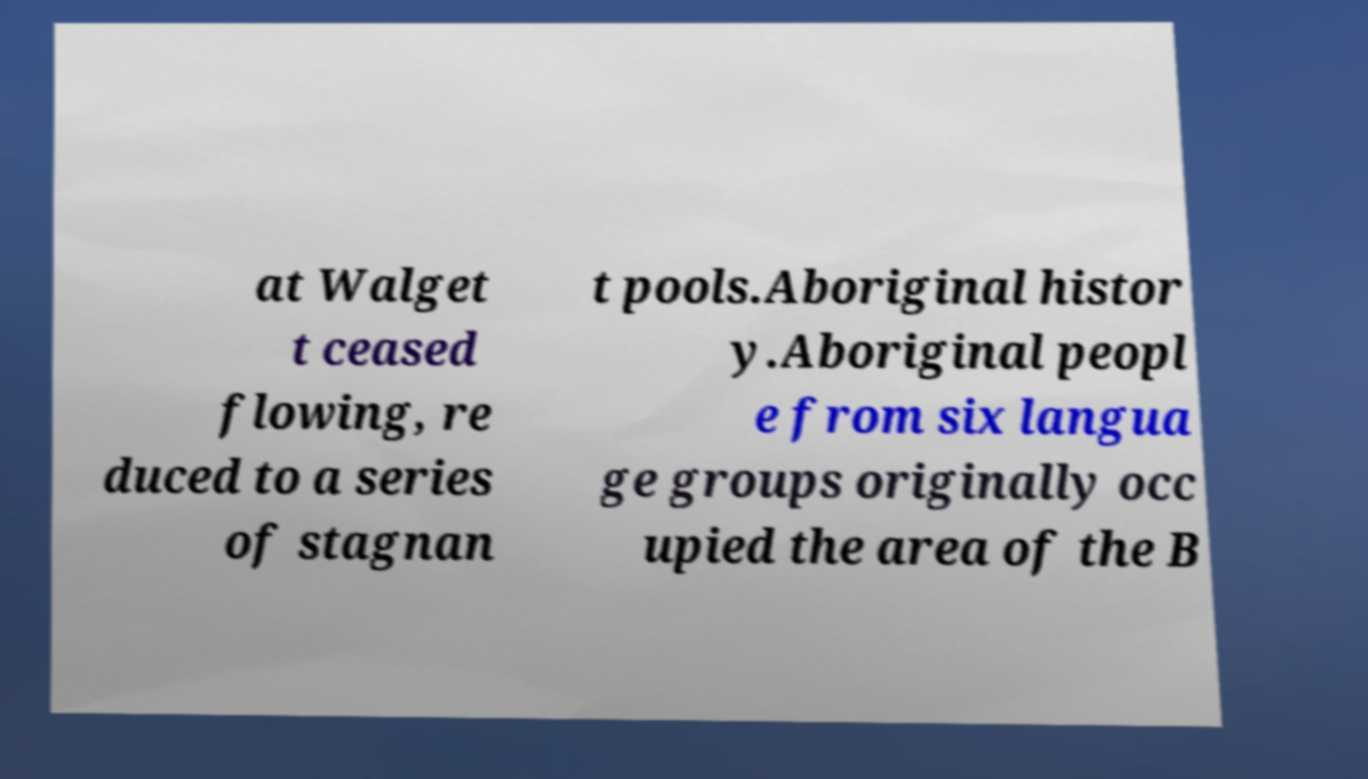What messages or text are displayed in this image? I need them in a readable, typed format. at Walget t ceased flowing, re duced to a series of stagnan t pools.Aboriginal histor y.Aboriginal peopl e from six langua ge groups originally occ upied the area of the B 